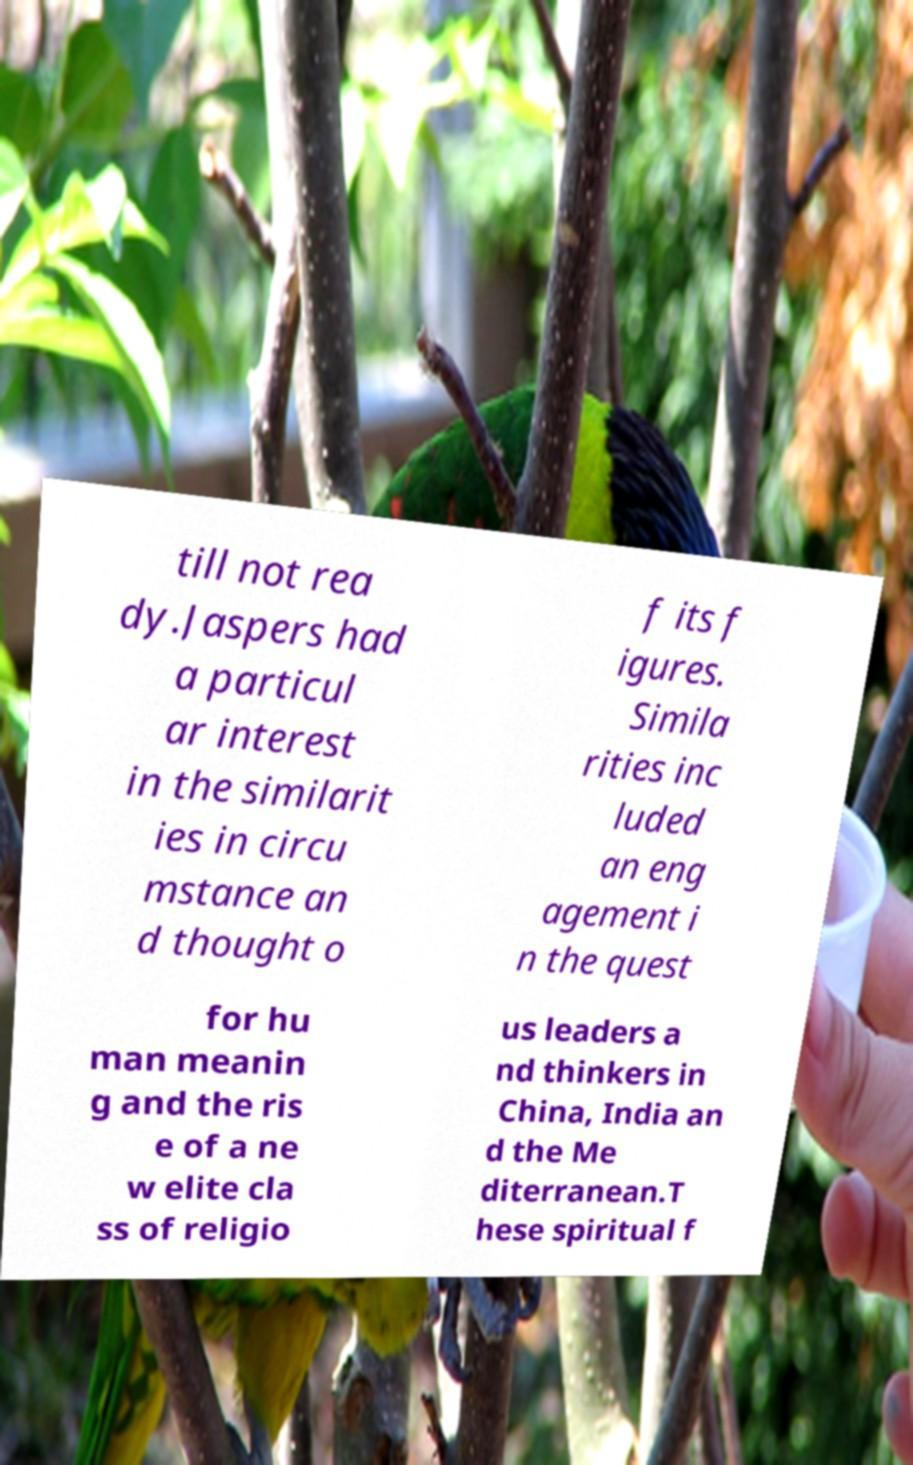Can you read and provide the text displayed in the image?This photo seems to have some interesting text. Can you extract and type it out for me? till not rea dy.Jaspers had a particul ar interest in the similarit ies in circu mstance an d thought o f its f igures. Simila rities inc luded an eng agement i n the quest for hu man meanin g and the ris e of a ne w elite cla ss of religio us leaders a nd thinkers in China, India an d the Me diterranean.T hese spiritual f 